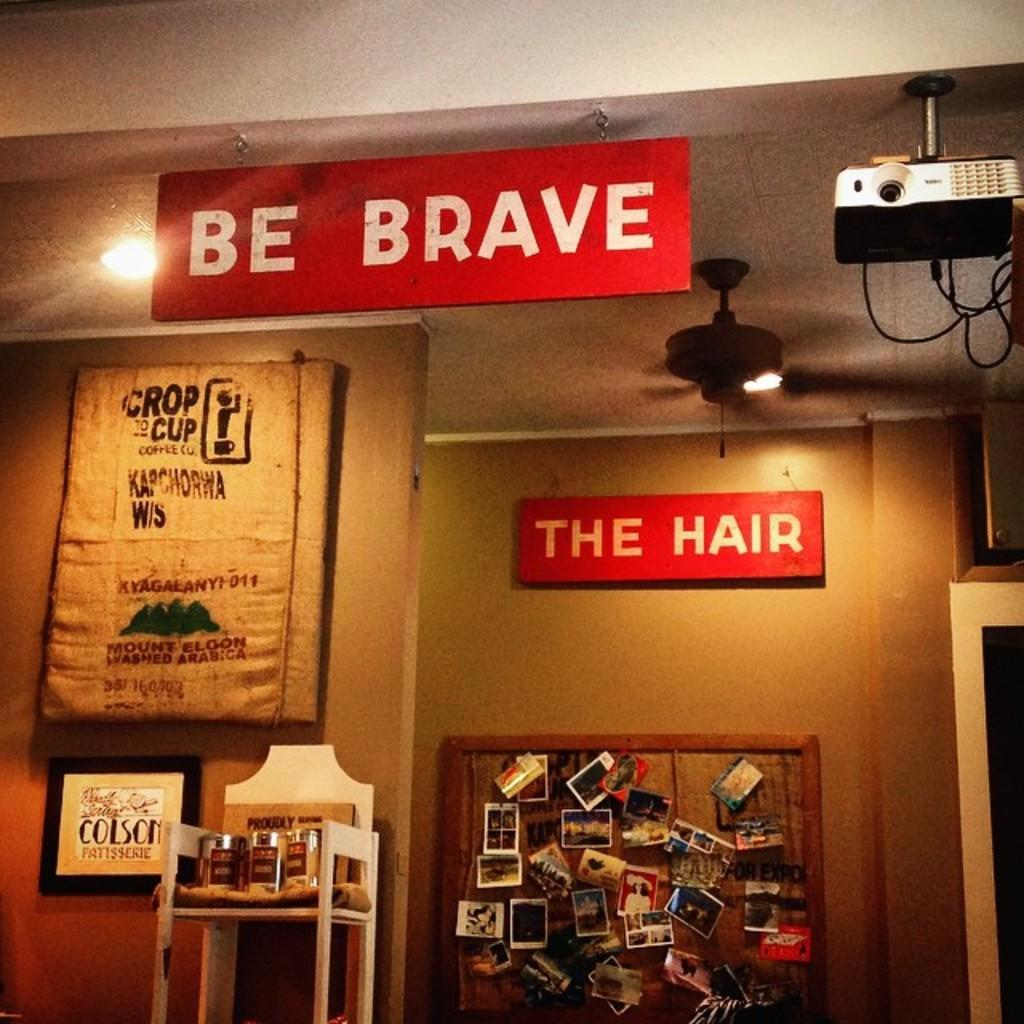Provide a one-sentence caption for the provided image. A red sign featuring the words "be brave" is displayed next to a projector. 